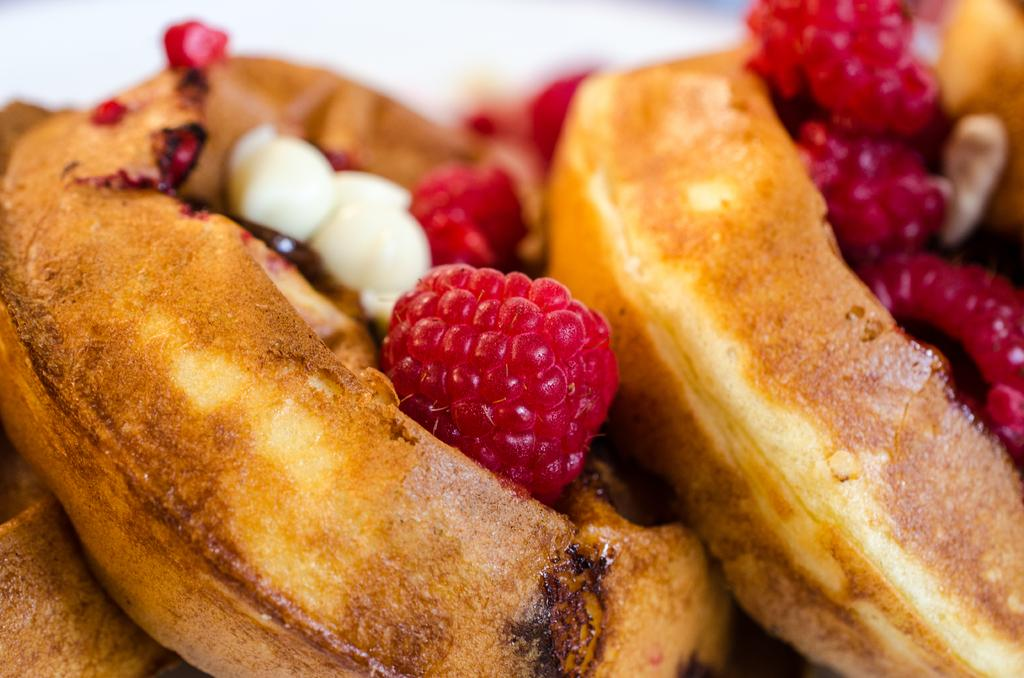What is present in the image? There is food in the image. Can you describe the food in more detail? Yes, there are raspberries on the food. What type of ball is being used to mix the rice in the image? There is no ball or rice present in the image; it only features food with raspberries. 